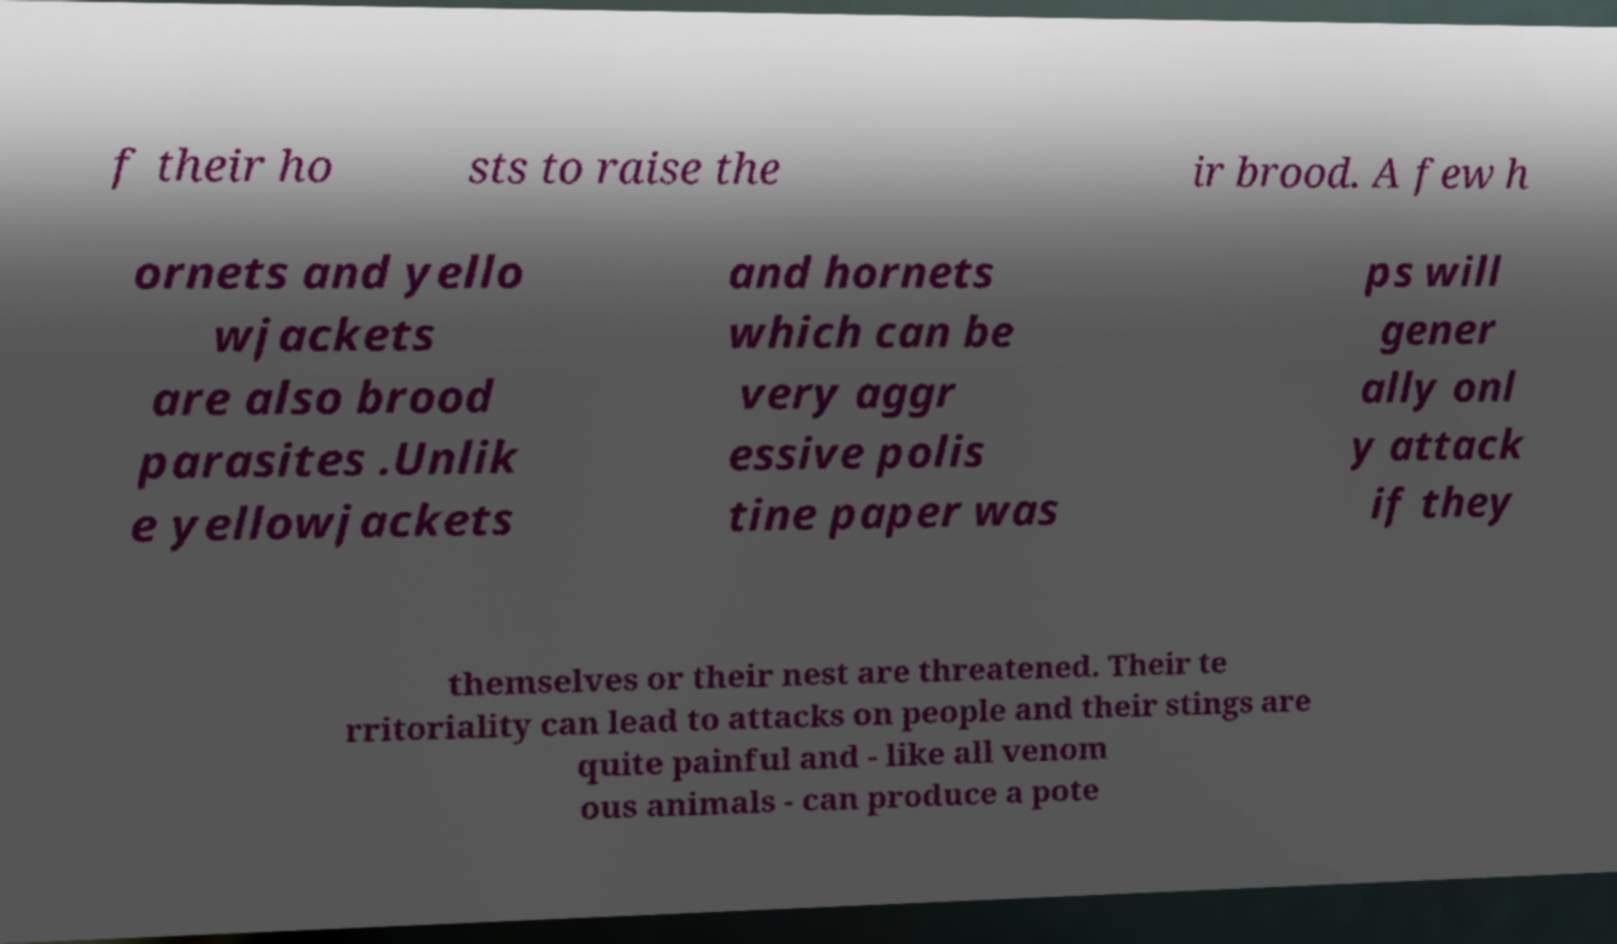Please read and relay the text visible in this image. What does it say? f their ho sts to raise the ir brood. A few h ornets and yello wjackets are also brood parasites .Unlik e yellowjackets and hornets which can be very aggr essive polis tine paper was ps will gener ally onl y attack if they themselves or their nest are threatened. Their te rritoriality can lead to attacks on people and their stings are quite painful and - like all venom ous animals - can produce a pote 